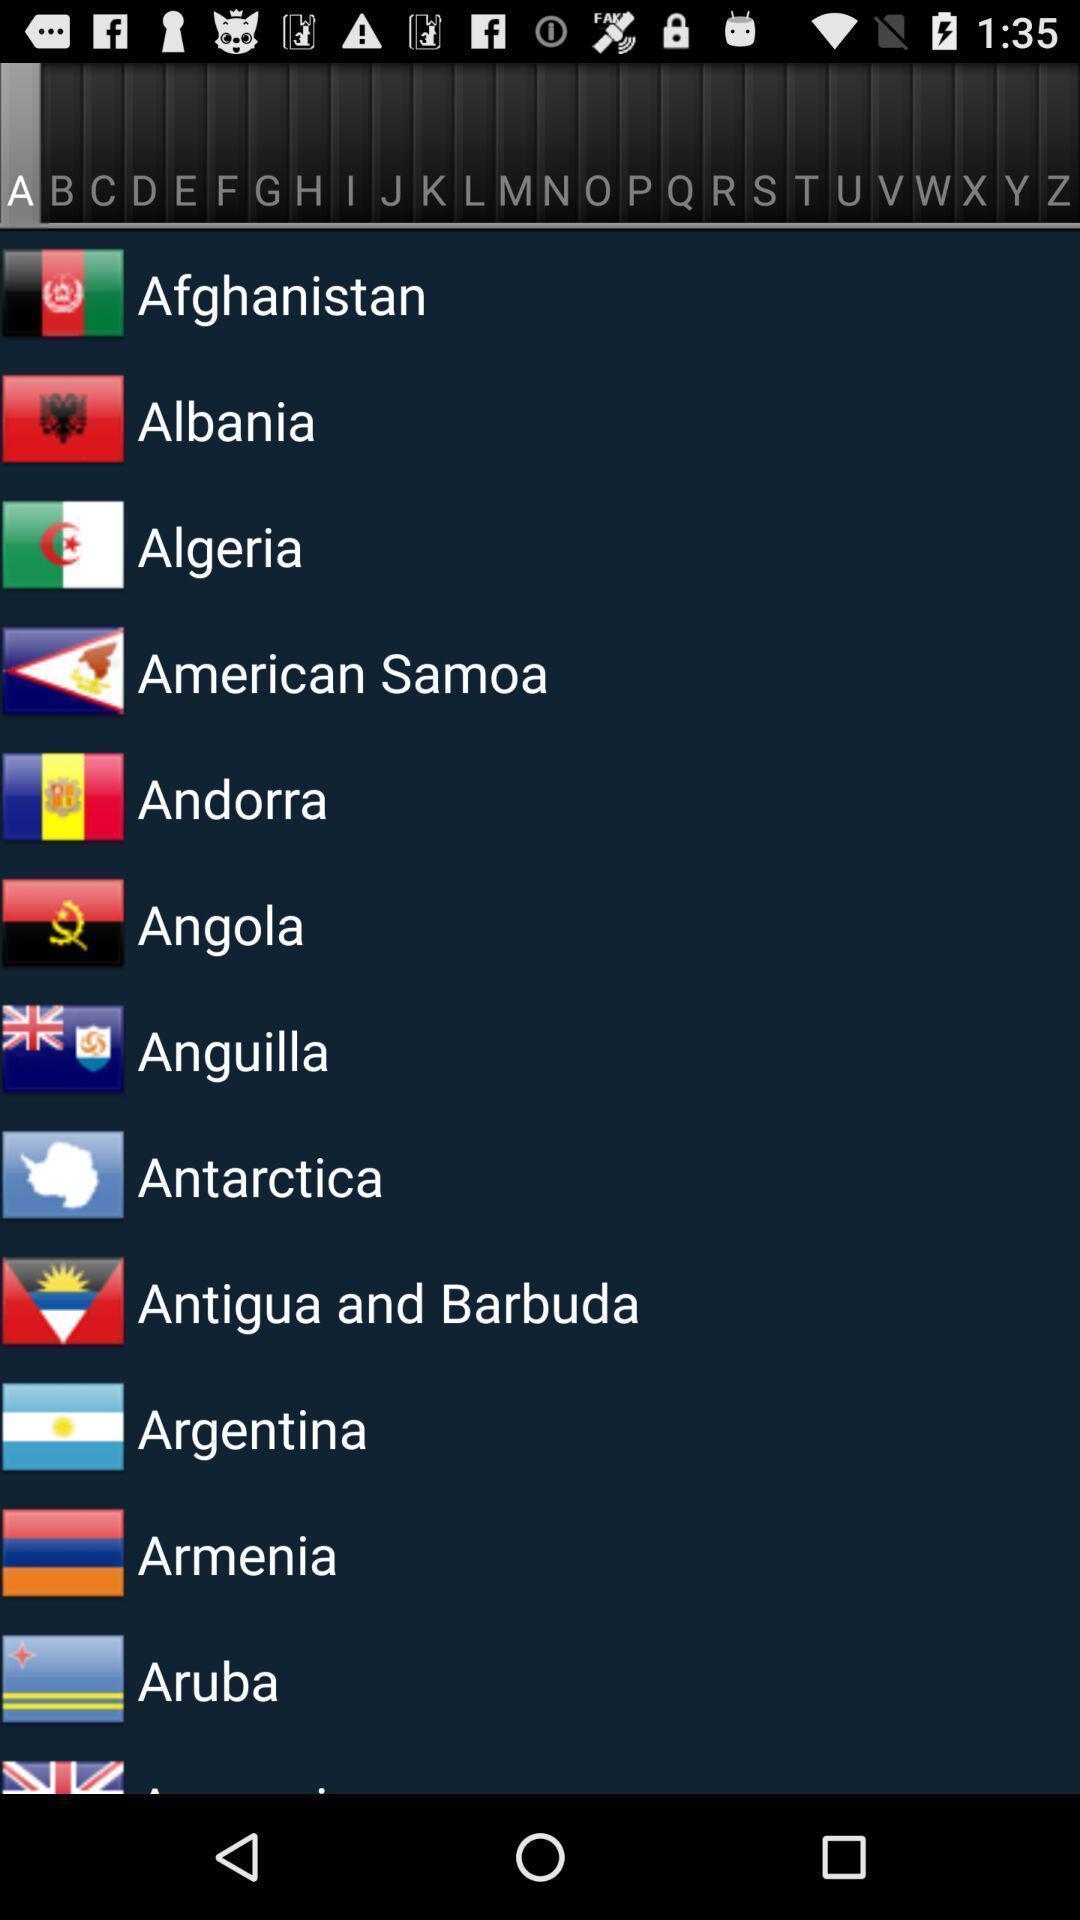Describe this image in words. Page with list of different country names. 